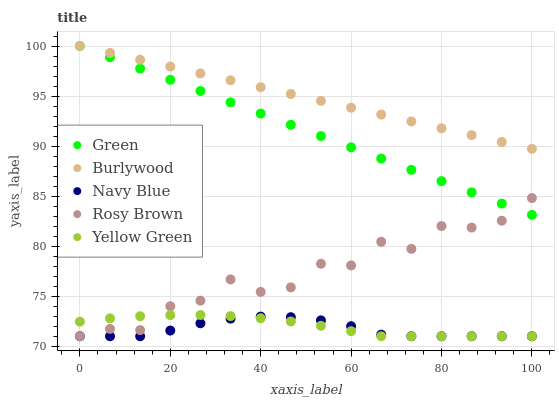Does Navy Blue have the minimum area under the curve?
Answer yes or no. Yes. Does Burlywood have the maximum area under the curve?
Answer yes or no. Yes. Does Rosy Brown have the minimum area under the curve?
Answer yes or no. No. Does Rosy Brown have the maximum area under the curve?
Answer yes or no. No. Is Green the smoothest?
Answer yes or no. Yes. Is Rosy Brown the roughest?
Answer yes or no. Yes. Is Navy Blue the smoothest?
Answer yes or no. No. Is Navy Blue the roughest?
Answer yes or no. No. Does Navy Blue have the lowest value?
Answer yes or no. Yes. Does Green have the lowest value?
Answer yes or no. No. Does Green have the highest value?
Answer yes or no. Yes. Does Rosy Brown have the highest value?
Answer yes or no. No. Is Navy Blue less than Burlywood?
Answer yes or no. Yes. Is Burlywood greater than Rosy Brown?
Answer yes or no. Yes. Does Navy Blue intersect Yellow Green?
Answer yes or no. Yes. Is Navy Blue less than Yellow Green?
Answer yes or no. No. Is Navy Blue greater than Yellow Green?
Answer yes or no. No. Does Navy Blue intersect Burlywood?
Answer yes or no. No. 